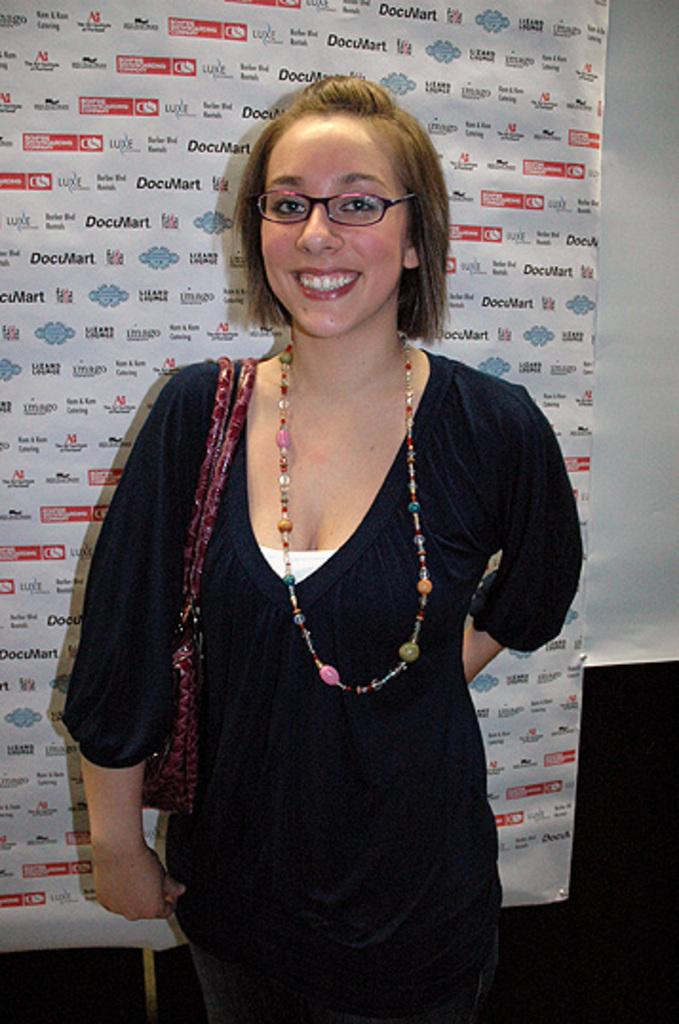Who is present in the image? There is a woman in the image. What is the woman wearing? The woman is wearing a black dress and spectacles. What is the woman's facial expression? The woman is smiling. What can be seen in the background of the image? There is a poster and a wall in the background. How many clover leaves are visible on the woman's dress in the image? There are no clover leaves visible on the woman's dress in the image. Can you tell me if the woman has a partner in the image? There is no information about a partner in the image; it only shows the woman. 